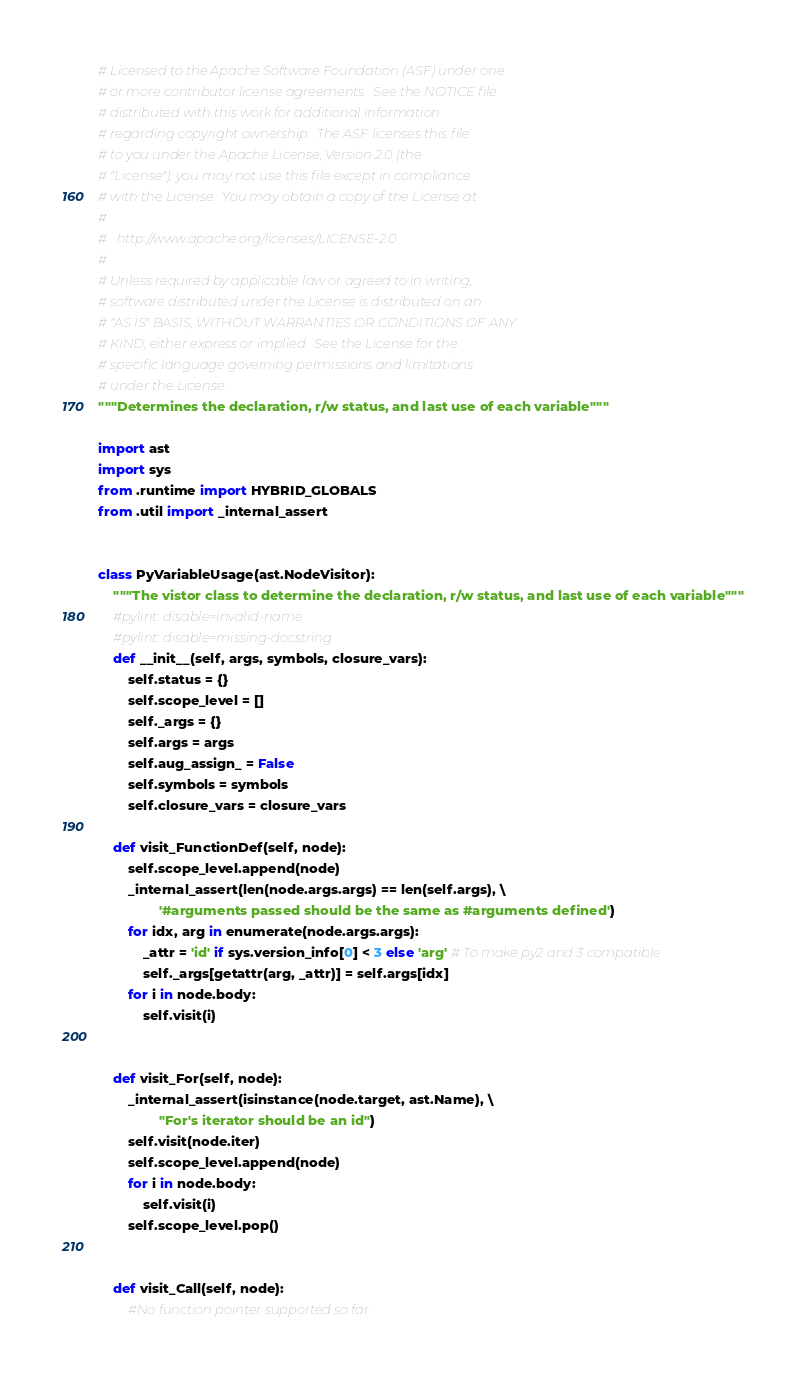Convert code to text. <code><loc_0><loc_0><loc_500><loc_500><_Python_># Licensed to the Apache Software Foundation (ASF) under one
# or more contributor license agreements.  See the NOTICE file
# distributed with this work for additional information
# regarding copyright ownership.  The ASF licenses this file
# to you under the Apache License, Version 2.0 (the
# "License"); you may not use this file except in compliance
# with the License.  You may obtain a copy of the License at
#
#   http://www.apache.org/licenses/LICENSE-2.0
#
# Unless required by applicable law or agreed to in writing,
# software distributed under the License is distributed on an
# "AS IS" BASIS, WITHOUT WARRANTIES OR CONDITIONS OF ANY
# KIND, either express or implied.  See the License for the
# specific language governing permissions and limitations
# under the License.
"""Determines the declaration, r/w status, and last use of each variable"""

import ast
import sys
from .runtime import HYBRID_GLOBALS
from .util import _internal_assert


class PyVariableUsage(ast.NodeVisitor):
    """The vistor class to determine the declaration, r/w status, and last use of each variable"""
    #pylint: disable=invalid-name
    #pylint: disable=missing-docstring
    def __init__(self, args, symbols, closure_vars):
        self.status = {}
        self.scope_level = []
        self._args = {}
        self.args = args
        self.aug_assign_ = False
        self.symbols = symbols
        self.closure_vars = closure_vars

    def visit_FunctionDef(self, node):
        self.scope_level.append(node)
        _internal_assert(len(node.args.args) == len(self.args), \
                '#arguments passed should be the same as #arguments defined')
        for idx, arg in enumerate(node.args.args):
            _attr = 'id' if sys.version_info[0] < 3 else 'arg' # To make py2 and 3 compatible
            self._args[getattr(arg, _attr)] = self.args[idx]
        for i in node.body:
            self.visit(i)


    def visit_For(self, node):
        _internal_assert(isinstance(node.target, ast.Name), \
                "For's iterator should be an id")
        self.visit(node.iter)
        self.scope_level.append(node)
        for i in node.body:
            self.visit(i)
        self.scope_level.pop()


    def visit_Call(self, node):
        #No function pointer supported so far</code> 